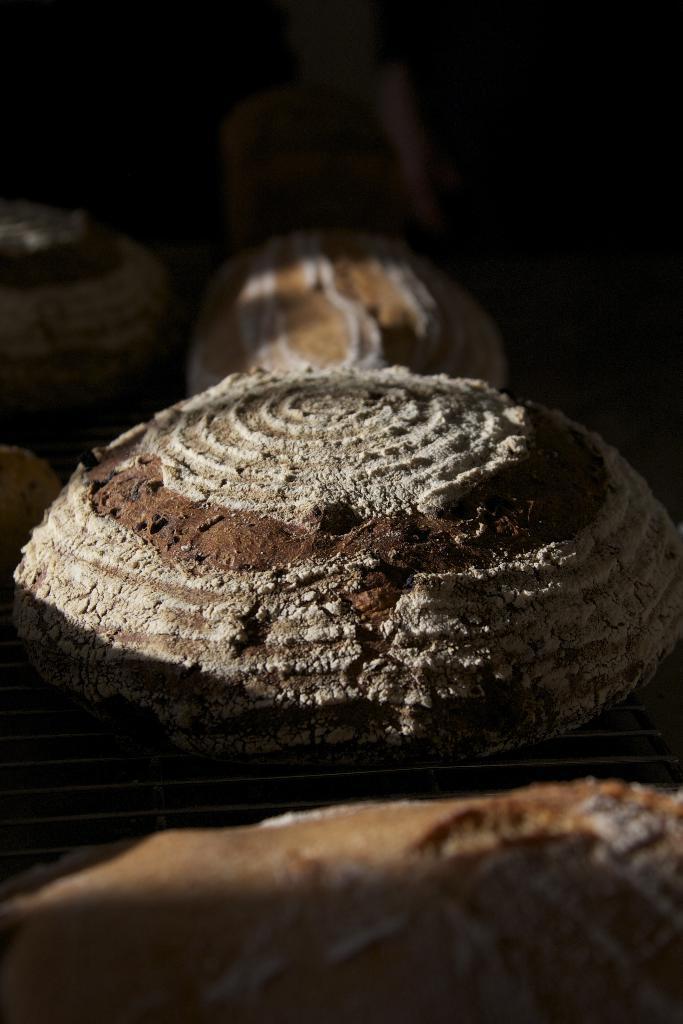Describe this image in one or two sentences. This is a structure which is in round shape and it is in brown color. In the background, there are some other structures. 